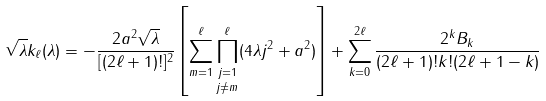Convert formula to latex. <formula><loc_0><loc_0><loc_500><loc_500>\sqrt { \lambda } k _ { \ell } ( \lambda ) = - \frac { 2 a ^ { 2 } \sqrt { \lambda } } { [ ( 2 \ell + 1 ) ! ] ^ { 2 } } \left [ \sum ^ { \ell } _ { m = 1 } \underset { j \ne m } { \prod ^ { \ell } _ { j = 1 } } ( 4 \lambda j ^ { 2 } + a ^ { 2 } ) \right ] + \sum ^ { 2 \ell } _ { k = 0 } \frac { 2 ^ { k } B _ { k } } { ( 2 \ell + 1 ) ! k ! ( 2 \ell + 1 - k ) }</formula> 